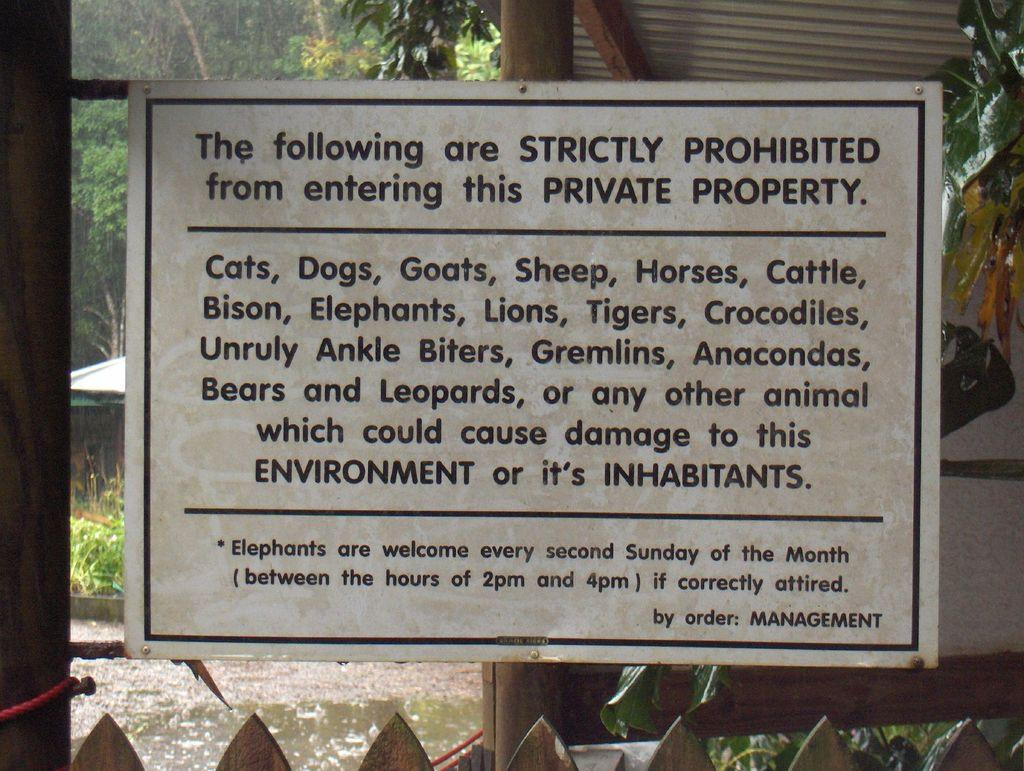What is the main object in the image? There is a board in the image. What other objects can be seen in the image? There are poles in the image. What can be seen in the background of the image? There are trees in the background of the image. What type of gold can be seen on the board in the image? There is no gold present on the board or in the image. 